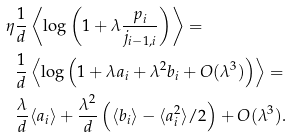Convert formula to latex. <formula><loc_0><loc_0><loc_500><loc_500>\eta & \frac { 1 } { d } \left \langle \log \left ( 1 + \lambda \frac { p _ { i } } { j _ { i - 1 , i } } \right ) \right \rangle = \\ & \frac { 1 } { d } \left \langle \log \left ( 1 + \lambda a _ { i } + \lambda ^ { 2 } b _ { i } + O ( \lambda ^ { 3 } ) \right ) \right \rangle = \\ & \frac { \lambda } { d } \langle a _ { i } \rangle + \frac { \lambda ^ { 2 } } { d } \left ( \langle b _ { i } \rangle - \langle a _ { i } ^ { 2 } \rangle / 2 \right ) + O ( \lambda ^ { 3 } ) .</formula> 